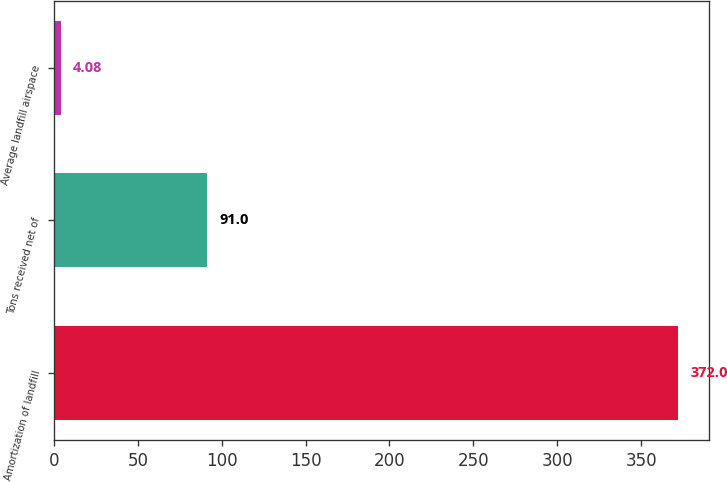Convert chart. <chart><loc_0><loc_0><loc_500><loc_500><bar_chart><fcel>Amortization of landfill<fcel>Tons received net of<fcel>Average landfill airspace<nl><fcel>372<fcel>91<fcel>4.08<nl></chart> 